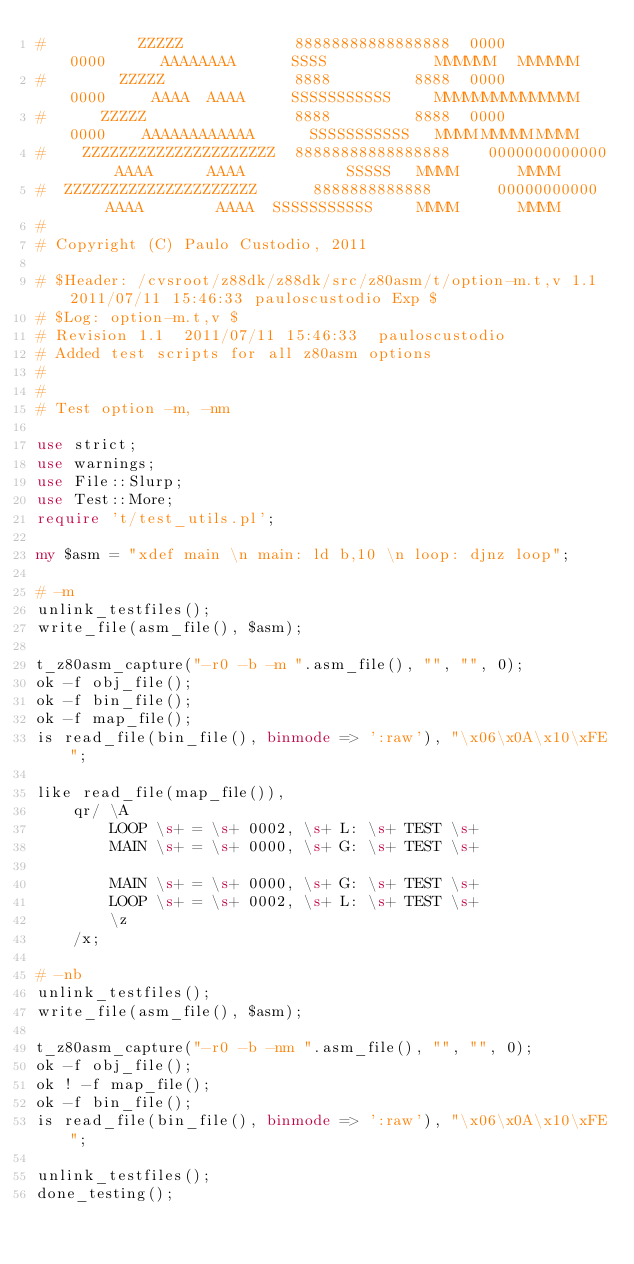<code> <loc_0><loc_0><loc_500><loc_500><_Perl_>#          ZZZZZ            88888888888888888  0000         0000      AAAAAAAA      SSSS            MMMMMM   MMMMMM
#        ZZZZZ              8888         8888  0000         0000     AAAA  AAAA     SSSSSSSSSSS     MMMMMMMMMMMMMMM
#      ZZZZZ                8888         8888  0000         0000    AAAAAAAAAAAA      SSSSSSSSSSS   MMMM MMMMM MMMM
#    ZZZZZZZZZZZZZZZZZZZZZ  88888888888888888    0000000000000     AAAA      AAAA           SSSSS   MMMM       MMMM
#  ZZZZZZZZZZZZZZZZZZZZZ      8888888888888       00000000000     AAAA        AAAA  SSSSSSSSSSS     MMMM       MMMM
#
# Copyright (C) Paulo Custodio, 2011

# $Header: /cvsroot/z88dk/z88dk/src/z80asm/t/option-m.t,v 1.1 2011/07/11 15:46:33 pauloscustodio Exp $
# $Log: option-m.t,v $
# Revision 1.1  2011/07/11 15:46:33  pauloscustodio
# Added test scripts for all z80asm options
#
#
# Test option -m, -nm

use strict;
use warnings;
use File::Slurp;
use Test::More;
require 't/test_utils.pl';

my $asm = "xdef main \n main: ld b,10 \n loop: djnz loop";

# -m
unlink_testfiles();
write_file(asm_file(), $asm);

t_z80asm_capture("-r0 -b -m ".asm_file(), "", "", 0);
ok -f obj_file();
ok -f bin_file();
ok -f map_file();
is read_file(bin_file(), binmode => ':raw'), "\x06\x0A\x10\xFE";

like read_file(map_file()),
	qr/ \A 
	    LOOP \s+ = \s+ 0002, \s+ L: \s+ TEST \s+
	    MAIN \s+ = \s+ 0000, \s+ G: \s+ TEST \s+
	    
	    MAIN \s+ = \s+ 0000, \s+ G: \s+ TEST \s+
	    LOOP \s+ = \s+ 0002, \s+ L: \s+ TEST \s+
	    \z
	/x;

# -nb
unlink_testfiles();
write_file(asm_file(), $asm);

t_z80asm_capture("-r0 -b -nm ".asm_file(), "", "", 0);
ok -f obj_file();
ok ! -f map_file();
ok -f bin_file();
is read_file(bin_file(), binmode => ':raw'), "\x06\x0A\x10\xFE";

unlink_testfiles();
done_testing();
</code> 